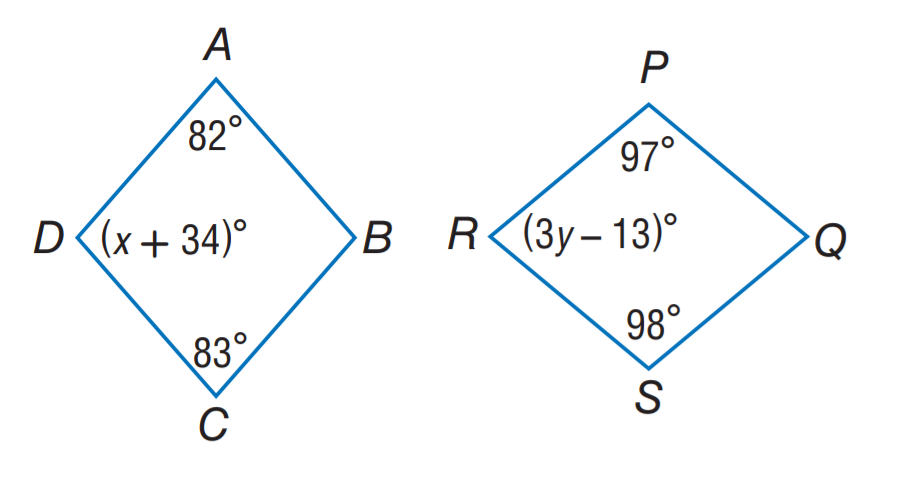Answer the mathemtical geometry problem and directly provide the correct option letter.
Question: A B C D \sim Q S R P. Find x.
Choices: A: 34 B: 63 C: 82 D: 83 B 